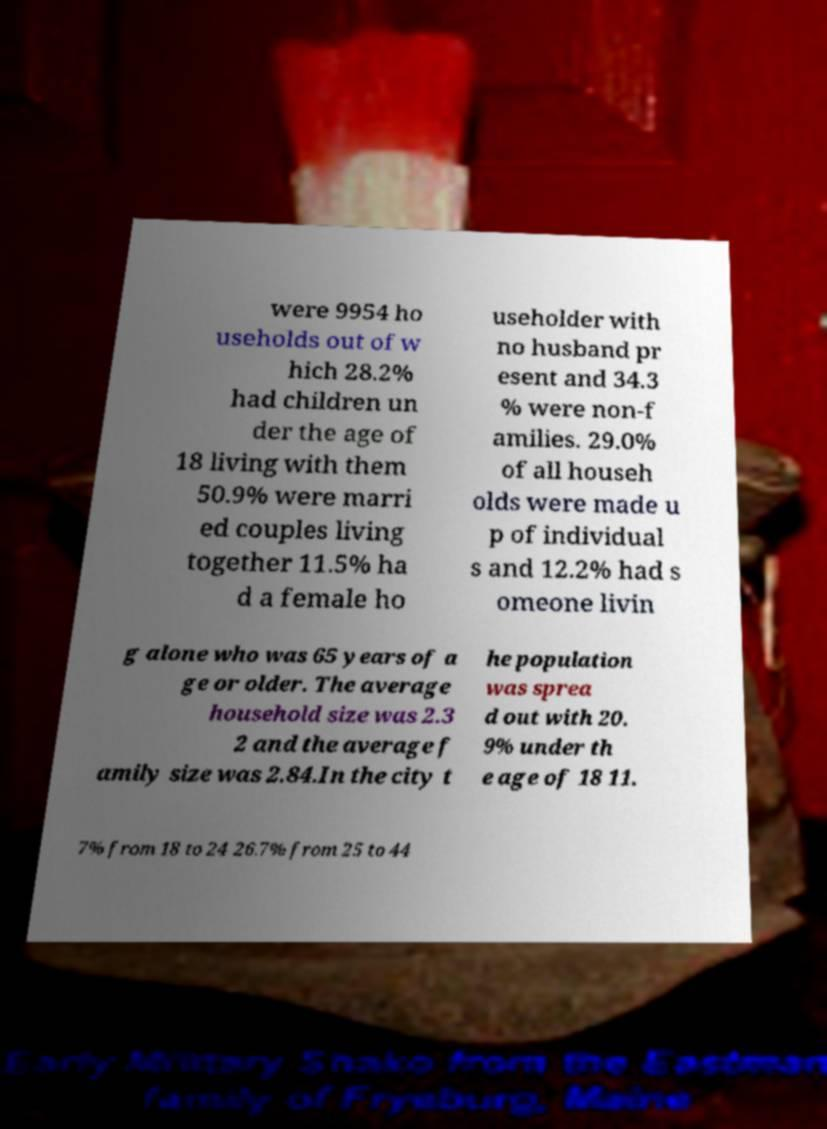I need the written content from this picture converted into text. Can you do that? were 9954 ho useholds out of w hich 28.2% had children un der the age of 18 living with them 50.9% were marri ed couples living together 11.5% ha d a female ho useholder with no husband pr esent and 34.3 % were non-f amilies. 29.0% of all househ olds were made u p of individual s and 12.2% had s omeone livin g alone who was 65 years of a ge or older. The average household size was 2.3 2 and the average f amily size was 2.84.In the city t he population was sprea d out with 20. 9% under th e age of 18 11. 7% from 18 to 24 26.7% from 25 to 44 